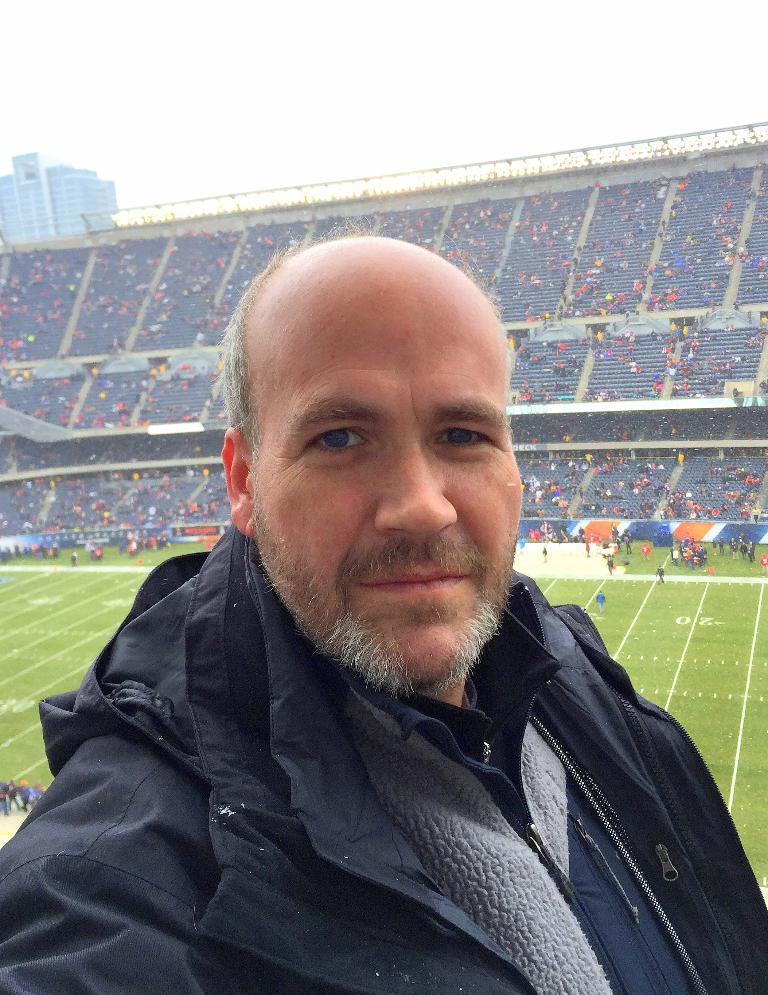Who is present in the image? There is a man in the image. What can be seen in the background of the image? There is a stadium, ground, people, a building, and the sky visible in the background of the image. What type of cloth is being recited by the man in the image? There is no cloth or recitation present in the image; it features a man and a background with various elements. 